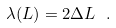Convert formula to latex. <formula><loc_0><loc_0><loc_500><loc_500>\lambda ( L ) = 2 \Delta L \ .</formula> 